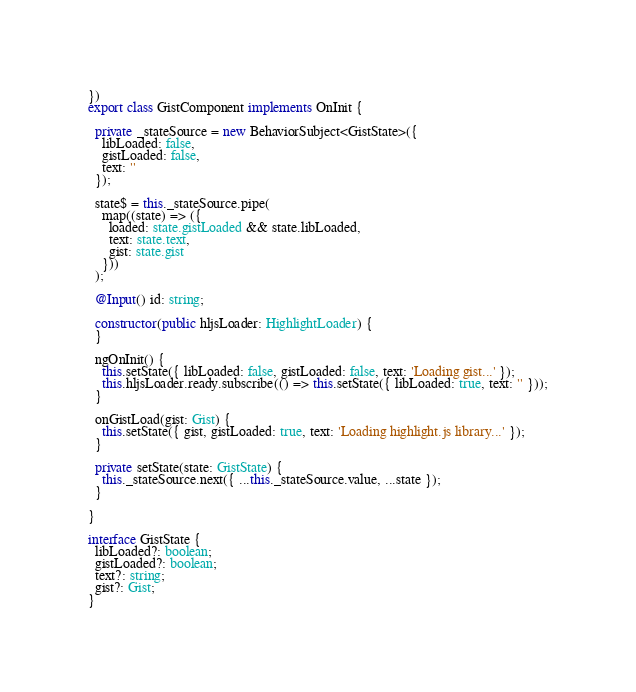Convert code to text. <code><loc_0><loc_0><loc_500><loc_500><_TypeScript_>})
export class GistComponent implements OnInit {

  private _stateSource = new BehaviorSubject<GistState>({
    libLoaded: false,
    gistLoaded: false,
    text: ''
  });

  state$ = this._stateSource.pipe(
    map((state) => ({
      loaded: state.gistLoaded && state.libLoaded,
      text: state.text,
      gist: state.gist
    }))
  );

  @Input() id: string;

  constructor(public hljsLoader: HighlightLoader) {
  }

  ngOnInit() {
    this.setState({ libLoaded: false, gistLoaded: false, text: 'Loading gist...' });
    this.hljsLoader.ready.subscribe(() => this.setState({ libLoaded: true, text: '' }));
  }

  onGistLoad(gist: Gist) {
    this.setState({ gist, gistLoaded: true, text: 'Loading highlight.js library...' });
  }

  private setState(state: GistState) {
    this._stateSource.next({ ...this._stateSource.value, ...state });
  }

}

interface GistState {
  libLoaded?: boolean;
  gistLoaded?: boolean;
  text?: string;
  gist?: Gist;
}
</code> 